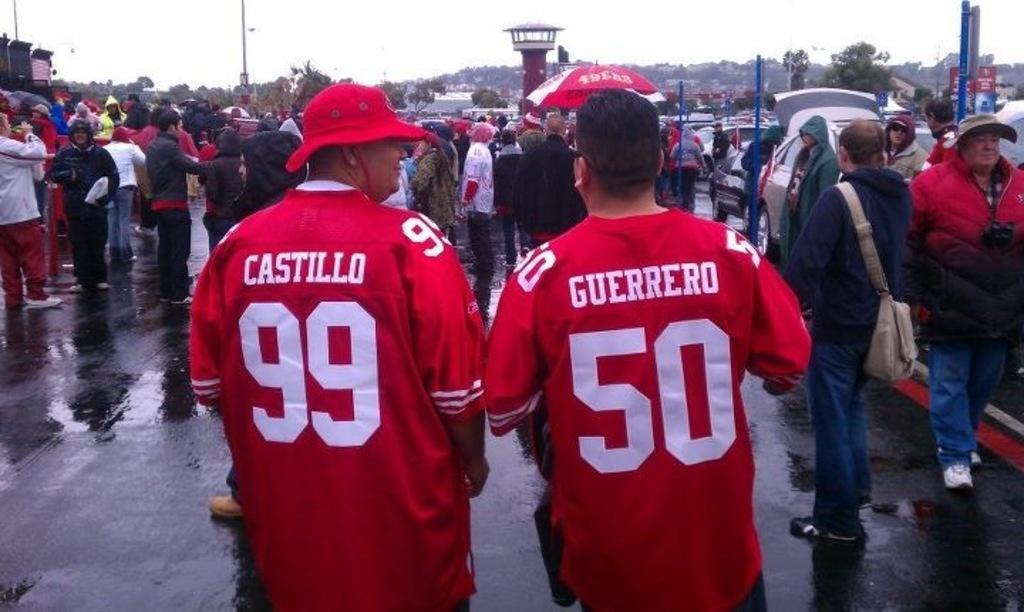<image>
Relay a brief, clear account of the picture shown. Two men wearing red 99 and 50 jerseys are standing among the crowd. 